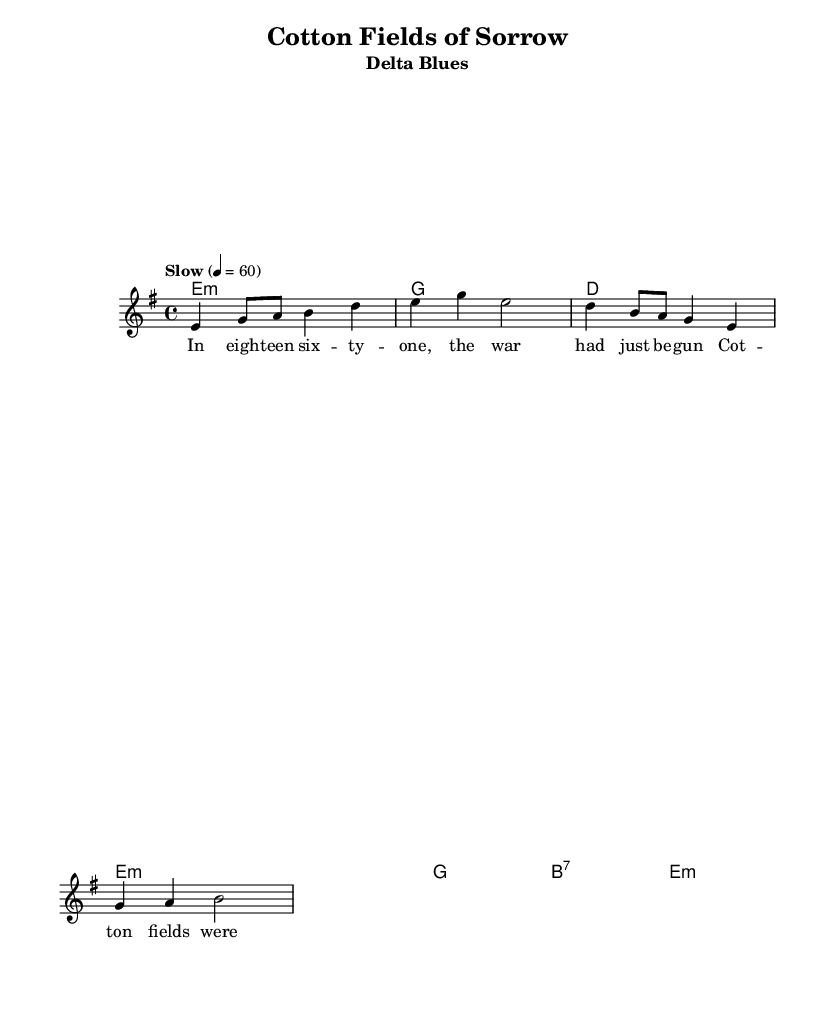What is the key signature of this music? The key signature indicated is E minor, which consists of one sharp (F#) and is derived from G major. The presence of the E minor chord in the harmony also confirms this key.
Answer: E minor What is the time signature of this music? The time signature is found at the beginning of the staff; it shows four beats per measure and is notated as 4/4, which is a common time signature in many genres, including blues.
Answer: 4/4 What is the tempo of the piece? The tempo marking at the beginning states "Slow" with a metronome marking of quarter note equals sixty beats per minute, suggesting a leisurely pace for the performance.
Answer: 60 What type of song is this? The title "Cotton Fields of Sorrow" and the presence of lyrics related to historical events indicate that this is a Delta Blues song, which often tells stories of hardship and experiences in the southern United States.
Answer: Delta Blues How many measures are in the melody? By counting the number of complete phrases notated in the melody section, we can see there are six measures presented in total.
Answer: Six What is the chord for the second measure? Looking at the chord changes outlined in the harmony section, the chord for the second measure is a G major chord, which is presented right after the E minor chord in the first measure.
Answer: G What historical context does this song reference? The lyrics mention "eighteen sixty-one" and describe silence in the cotton fields as men marched, referencing the Civil War, a significant historical event in the American South.
Answer: Civil War 